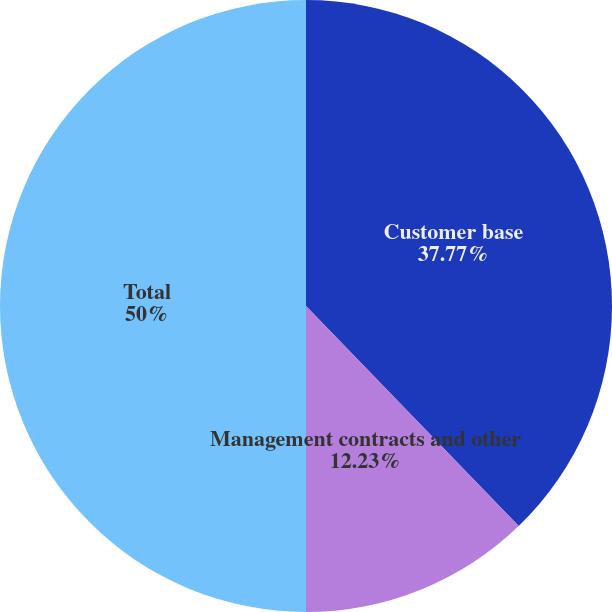<chart> <loc_0><loc_0><loc_500><loc_500><pie_chart><fcel>Customer base<fcel>Management contracts and other<fcel>Total<nl><fcel>37.77%<fcel>12.23%<fcel>50.0%<nl></chart> 